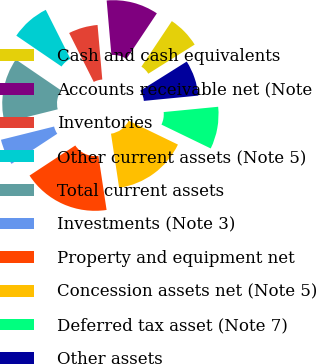Convert chart to OTSL. <chart><loc_0><loc_0><loc_500><loc_500><pie_chart><fcel>Cash and cash equivalents<fcel>Accounts receivable net (Note<fcel>Inventories<fcel>Other current assets (Note 5)<fcel>Total current assets<fcel>Investments (Note 3)<fcel>Property and equipment net<fcel>Concession assets net (Note 5)<fcel>Deferred tax asset (Note 7)<fcel>Other assets<nl><fcel>6.71%<fcel>10.74%<fcel>6.04%<fcel>8.05%<fcel>13.42%<fcel>5.37%<fcel>18.12%<fcel>15.44%<fcel>8.72%<fcel>7.38%<nl></chart> 